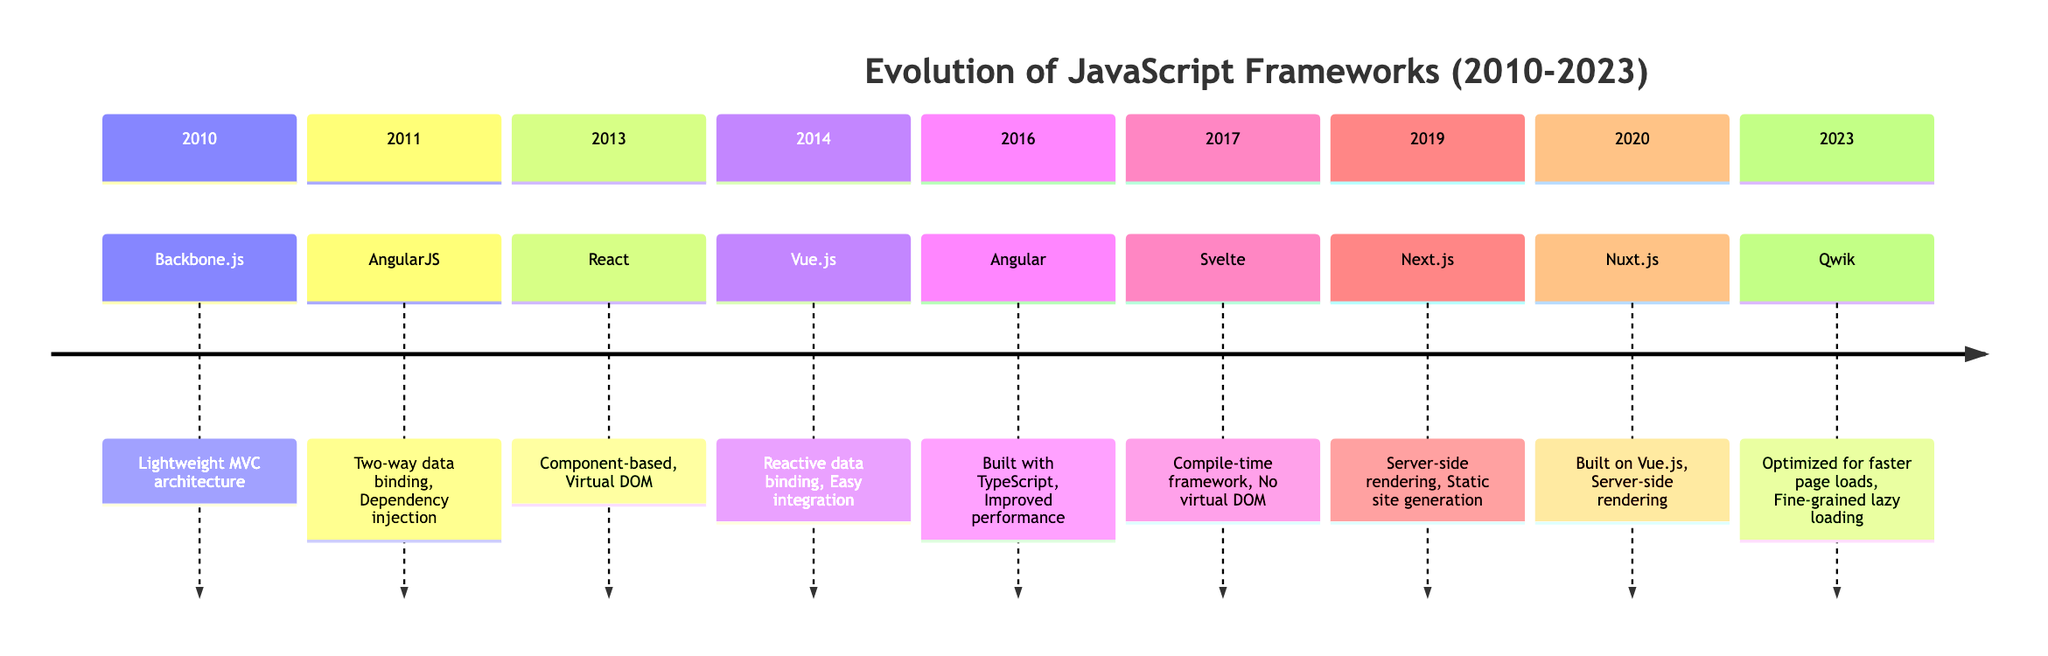What year was Backbone.js released? Backbone.js was released in October 2010, as indicated in the timeline under the 2010 section.
Answer: 2010 Which framework was released in 2016? The timeline shows that Angular was released in September 2016, found under the 2016 section.
Answer: Angular How many frameworks were introduced between 2010 and 2023? By counting the entries in the timeline from 2010 to 2023, we find a total of 9 frameworks listed.
Answer: 9 What is a key feature of React? Among the key features listed for React in 2013, "Component-based architecture" is highlighted.
Answer: Component-based architecture What distinguishes Svelte from other frameworks listed? Svelte is notable for being a "Compile-time framework" and having "No virtual DOM," which sets it apart from others in the timeline.
Answer: Compile-time framework Which framework introduced two-way data binding? The timeline identifies AngularJS as the framework that introduced "Two-way data binding" in 2011.
Answer: AngularJS Which frameworks are built on top of other frameworks? Nuxt.js, built on top of Vue.js, is mentioned in the timeline as one of the frameworks that rely on others, specifically under the 2020 section.
Answer: Nuxt.js What major improvement was made in Angular compared to AngularJS? The timeline states Angular was rewritten and "Built with TypeScript," a significant improvement over AngularJS.
Answer: Built with TypeScript What features of Qwik support performance optimization? Qwik's key features listed in 2023 include "Optimized for faster page loads" and "Fine-grained lazy loading," indicating its focus on performance.
Answer: Optimized for faster page loads 